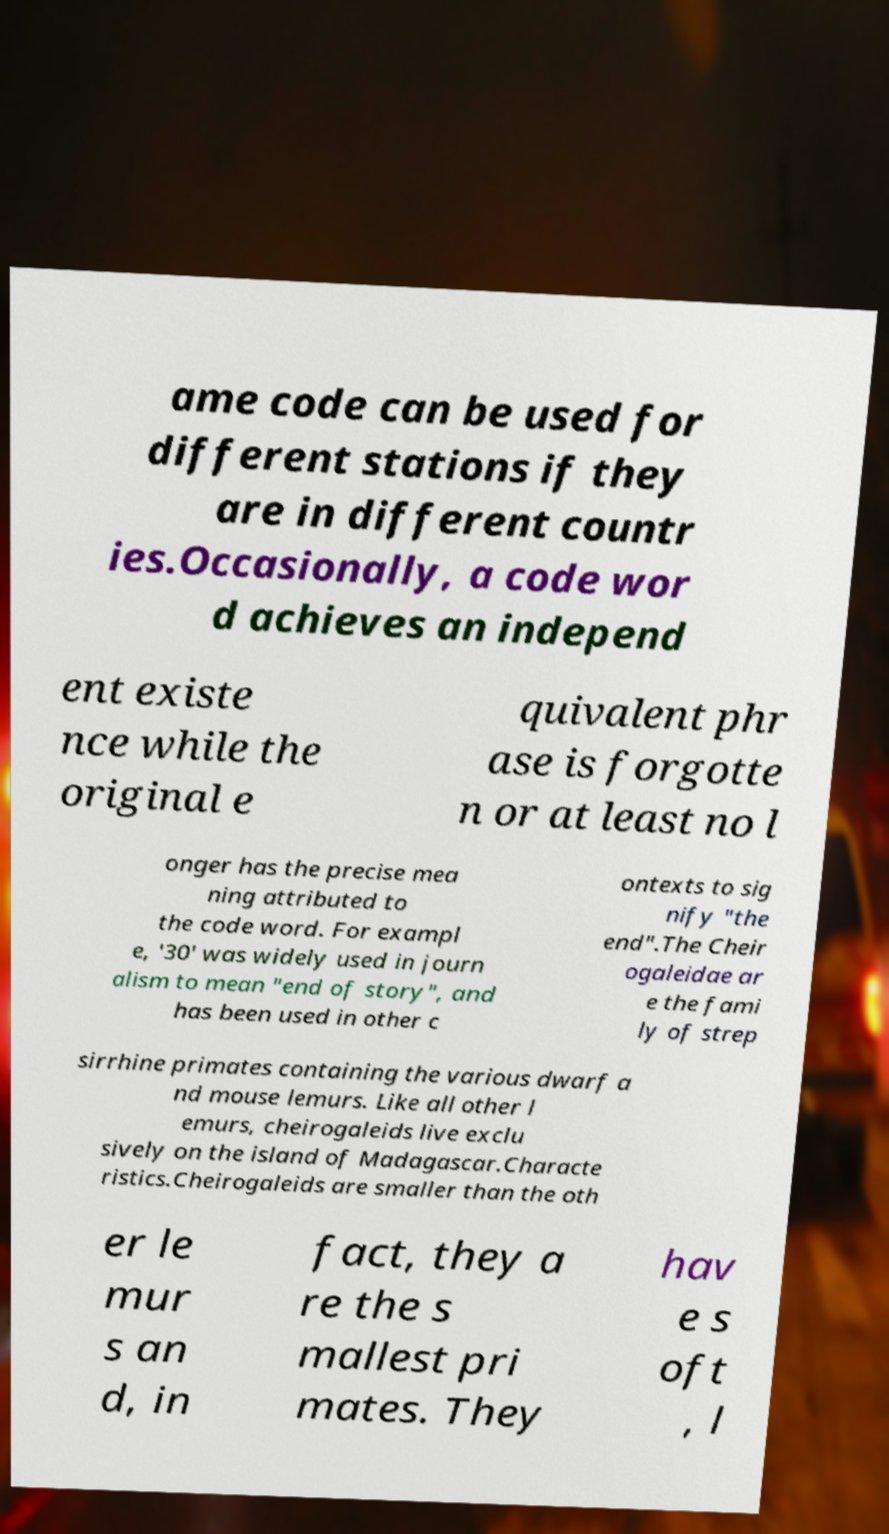Please identify and transcribe the text found in this image. ame code can be used for different stations if they are in different countr ies.Occasionally, a code wor d achieves an independ ent existe nce while the original e quivalent phr ase is forgotte n or at least no l onger has the precise mea ning attributed to the code word. For exampl e, '30' was widely used in journ alism to mean "end of story", and has been used in other c ontexts to sig nify "the end".The Cheir ogaleidae ar e the fami ly of strep sirrhine primates containing the various dwarf a nd mouse lemurs. Like all other l emurs, cheirogaleids live exclu sively on the island of Madagascar.Characte ristics.Cheirogaleids are smaller than the oth er le mur s an d, in fact, they a re the s mallest pri mates. They hav e s oft , l 